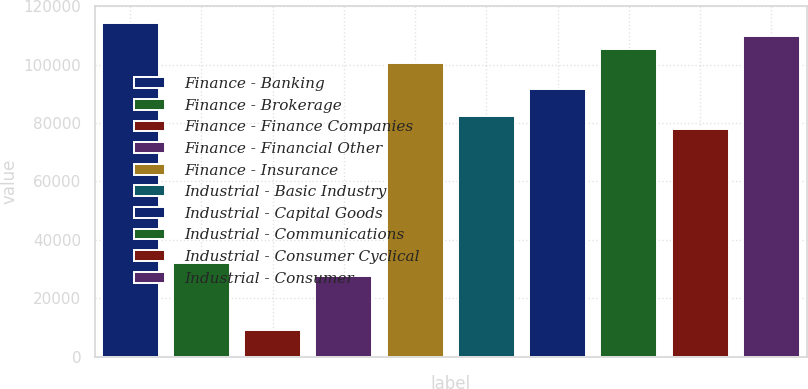Convert chart to OTSL. <chart><loc_0><loc_0><loc_500><loc_500><bar_chart><fcel>Finance - Banking<fcel>Finance - Brokerage<fcel>Finance - Finance Companies<fcel>Finance - Financial Other<fcel>Finance - Insurance<fcel>Industrial - Basic Industry<fcel>Industrial - Capital Goods<fcel>Industrial - Communications<fcel>Industrial - Consumer Cyclical<fcel>Industrial - Consumer<nl><fcel>114358<fcel>32092.1<fcel>9240.6<fcel>27521.8<fcel>100647<fcel>82365.4<fcel>91506<fcel>105217<fcel>77795.1<fcel>109787<nl></chart> 